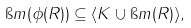Convert formula to latex. <formula><loc_0><loc_0><loc_500><loc_500>\i m ( \phi ( R ) ) \subseteq \langle K \cup \i m ( R ) \rangle ,</formula> 